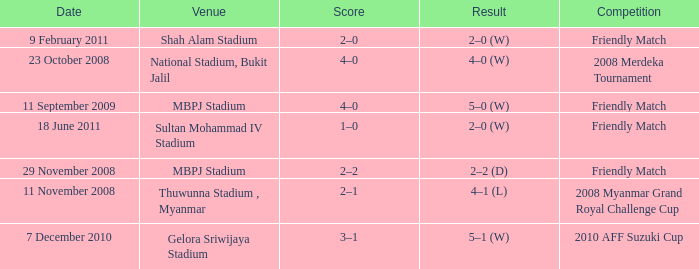What Competition had a Score of 2–0? Friendly Match. 